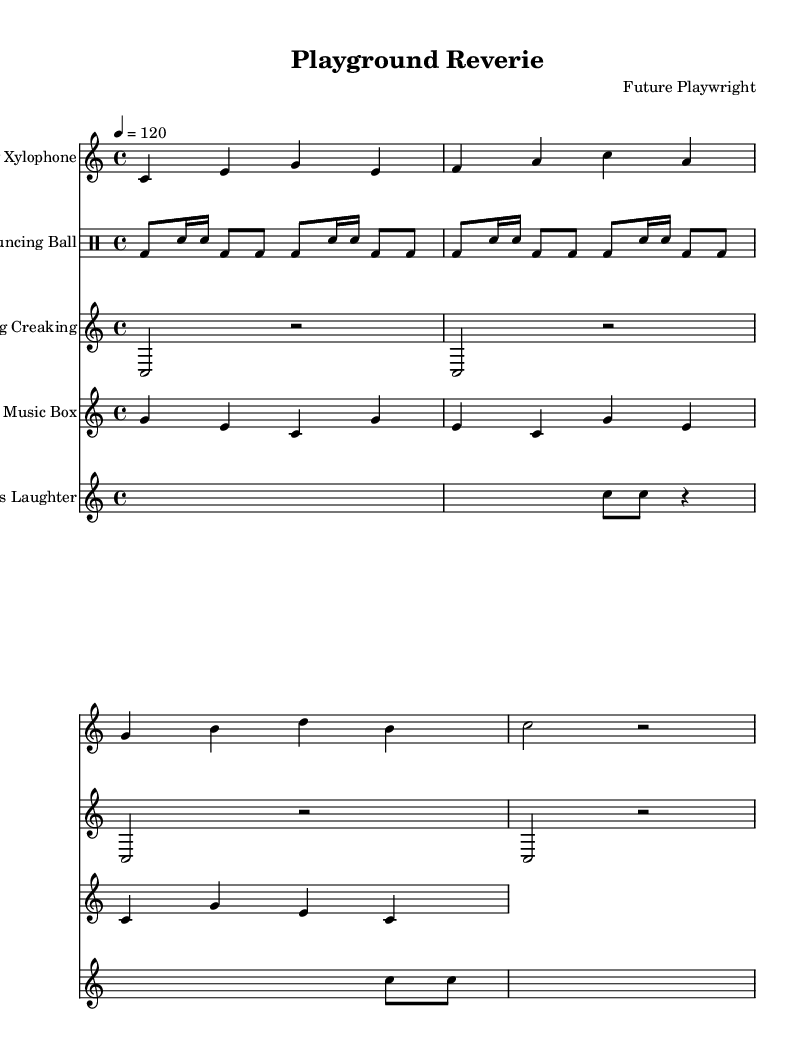What is the key signature of this music? The key signature is C major, which has no sharps or flats, as indicated at the beginning of the score.
Answer: C major What is the time signature of the toy xylophone section? The toy xylophone section has a time signature of 4/4, as denoted at the beginning of that specific staff.
Answer: 4/4 How many measures are in the wind-up music box section? The wind-up music box section has 4 measures; this can be counted as there are four repeated phrases in its notation.
Answer: 4 What is the tempo marking for the overall piece? The tempo marking for the piece is 120 beats per minute, indicated in the global settings section at the beginning of the score.
Answer: 120 Which instrument is indicated for the section titled "Swing Creaking"? The instrument for this section is labeled as "Swing Creaking," as seen in the staff label preceding the music notation.
Answer: Swing Creaking What rhythmic pattern is used for the bouncing ball? The rhythmic pattern consists of a combination of bass drum and snare hits, which can be identified in the drum notation throughout the section.
Answer: Bass drum and snare How many times does the children’s laughter section contain a silence? The children’s laughter section contains 3 instances of silence, which can be identified by counting rests in the notation.
Answer: 3 